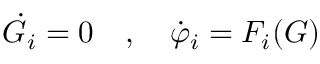<formula> <loc_0><loc_0><loc_500><loc_500>{ \dot { G } } _ { i } = 0 \quad , \quad \dot { \varphi } _ { i } = F _ { i } ( G )</formula> 